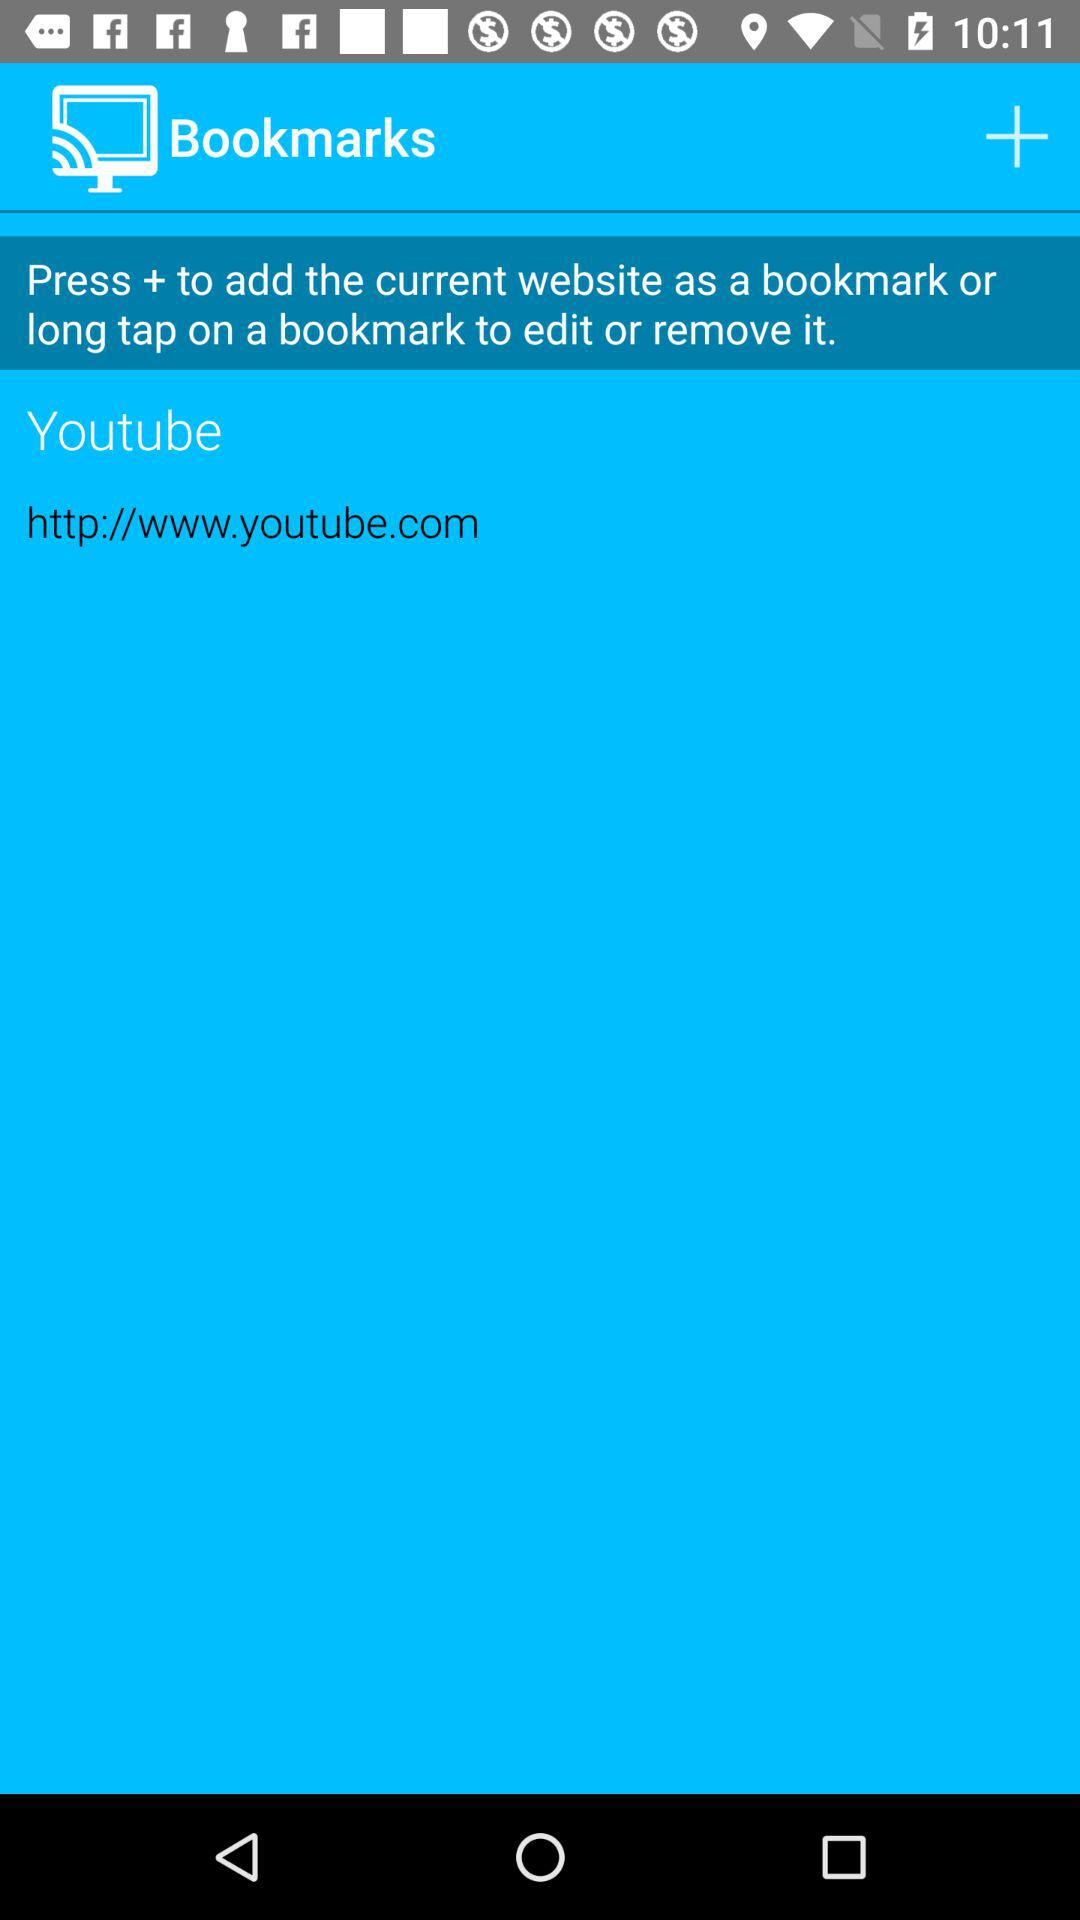What is the given URL address of "YouTube"? The given URL address of "YouTube" is http://www.youtube.com. 